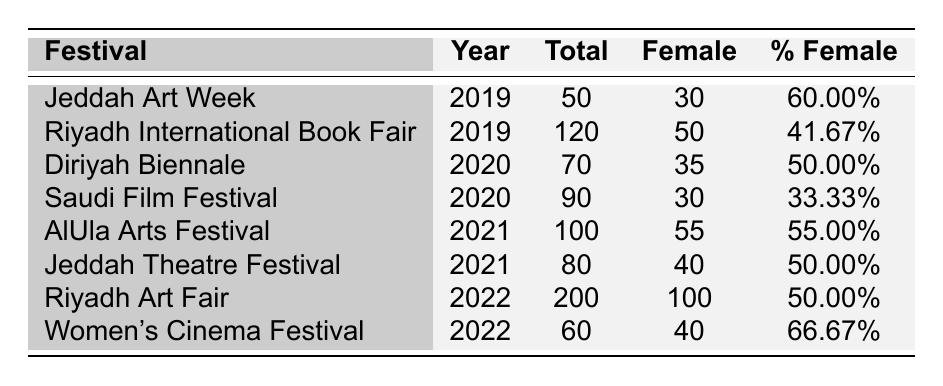What was the highest percentage of female participation in a festival from 2019 to 2022? The table shows the percentage of female participants for each festival. The highest percentage is 66.67%, which occurred at the Women’s Cinema Festival in 2022.
Answer: 66.67% Which festival had the lowest percentage of female participants? By examining the percentages in the table, the Saudi Film Festival in 2020 had the lowest percentage at 33.33%.
Answer: 33.33% How many total participants were there in the Riyadh Art Fair? The table indicates that the Riyadh Art Fair in 2022 had 200 total participants.
Answer: 200 What was the female participation percentage in the AlUla Arts Festival? The table states that the percentage of female participants in the AlUla Arts Festival in 2021 was 55.00%.
Answer: 55.00% How many festivals had more than 50 total participants and included at least 50% female representation? The festivals that meet both criteria are: Jeddah Art Week (2019), Diriyah Biennale (2020), AlUla Arts Festival (2021), and Riyadh Art Fair (2022). Thus, there are four such festivals.
Answer: 4 What is the total number of female participants across all festivals listed in the table? To find the total female participants, I add the female participants from each festival: 30 + 50 + 35 + 30 + 55 + 40 + 100 + 40 = 380.
Answer: 380 Did more female artists participate in 2021 compared to 2020? In 2021, there were a total of 55 female artists at the AlUla Arts Festival and 40 female actors at the Jeddah Theatre Festival, totaling 95. In 2020, there were 35 female artists at the Diriyah Biennale and 30 female filmmakers at the Saudi Film Festival, totaling 65. Since 95 (2021) is greater than 65 (2020), the answer is yes.
Answer: Yes What was the change in the number of female participants from the Riyadh International Book Fair in 2019 to the Riyadh Art Fair in 2022? In 2019, the Riyadh International Book Fair had 50 female authors, and in 2022, the Riyadh Art Fair had 100 female artists. The change in the number of female participants is 100 - 50 = 50 more female participants from 2019 to 2022.
Answer: 50 How does the total number of participants compare between 2020 and 2021? The total participants in 2020 were 70 (Diriyah Biennale) + 90 (Saudi Film Festival) = 160. In 2021, it was 100 (AlUla Arts Festival) + 80 (Jeddah Theatre Festival) = 180. Since 180 is greater than 160, more participants attended festivals in 2021 than in 2020.
Answer: Yes 